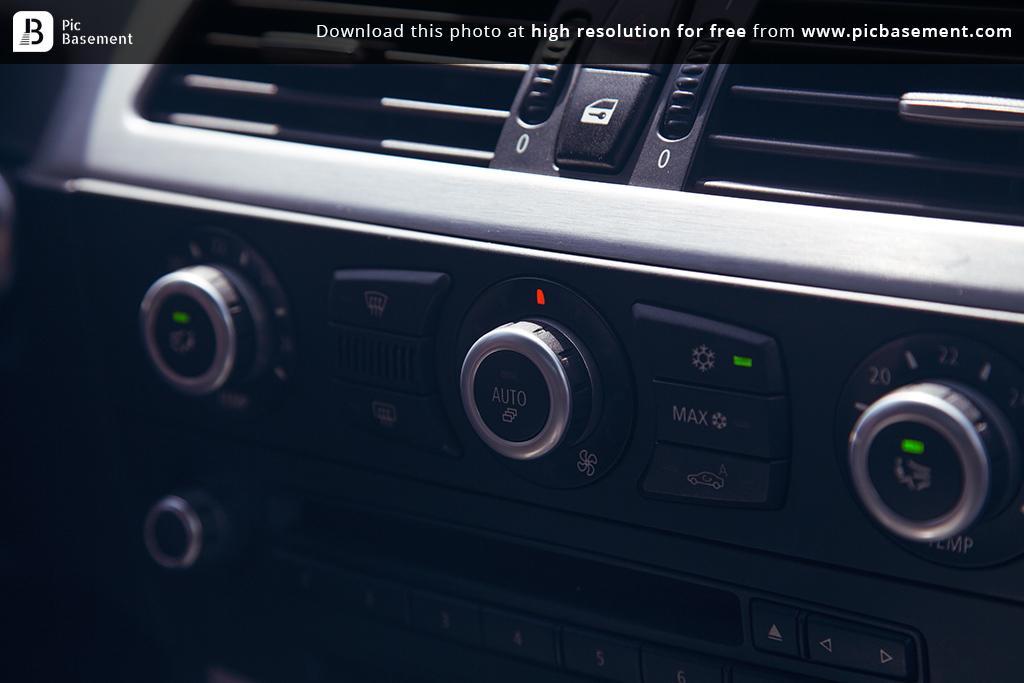Could you give a brief overview of what you see in this image? In this we can see interior part of the car, there are two AAC blocks, and few buttons. 